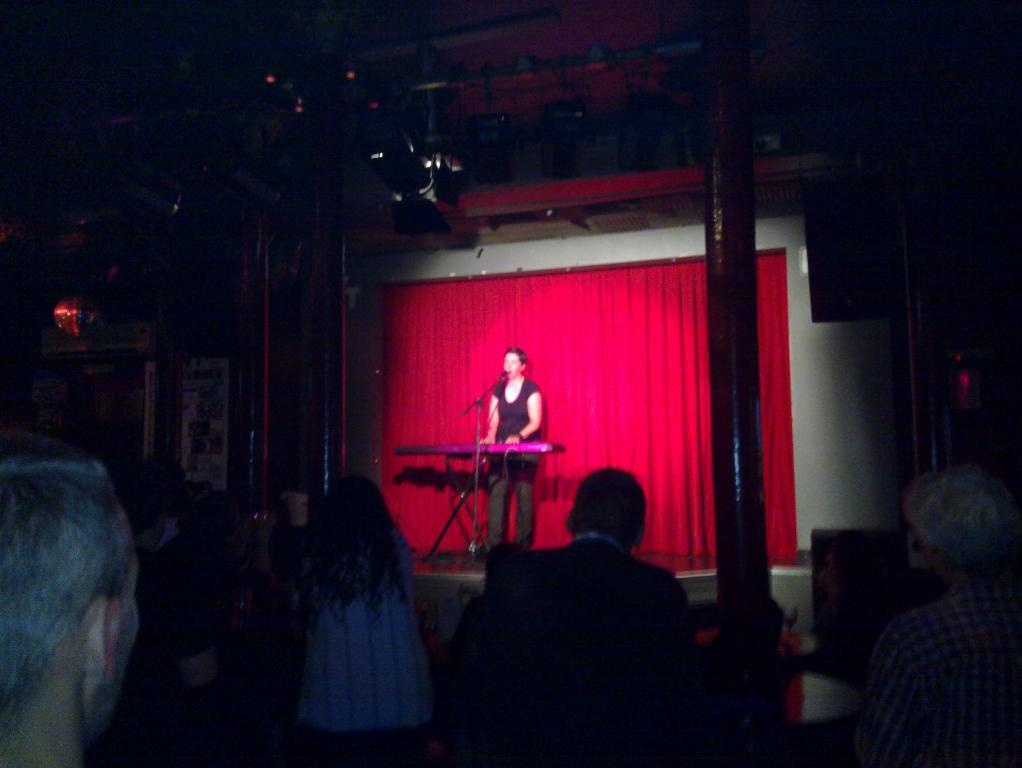What can be seen at the bottom of the image? There are persons at the bottom of the image. What is the main subject in the middle of the image? There is a woman in the middle of the image. What is the woman doing? The woman is singing. What object is the woman holding? The woman is holding a microphone. Can you see a robin perched on the woman's shoulder while she sings? No, there is no robin present in the image. Is the woman wearing a boot while singing? There is no mention of any boots in the image, and the woman's footwear is not visible. 